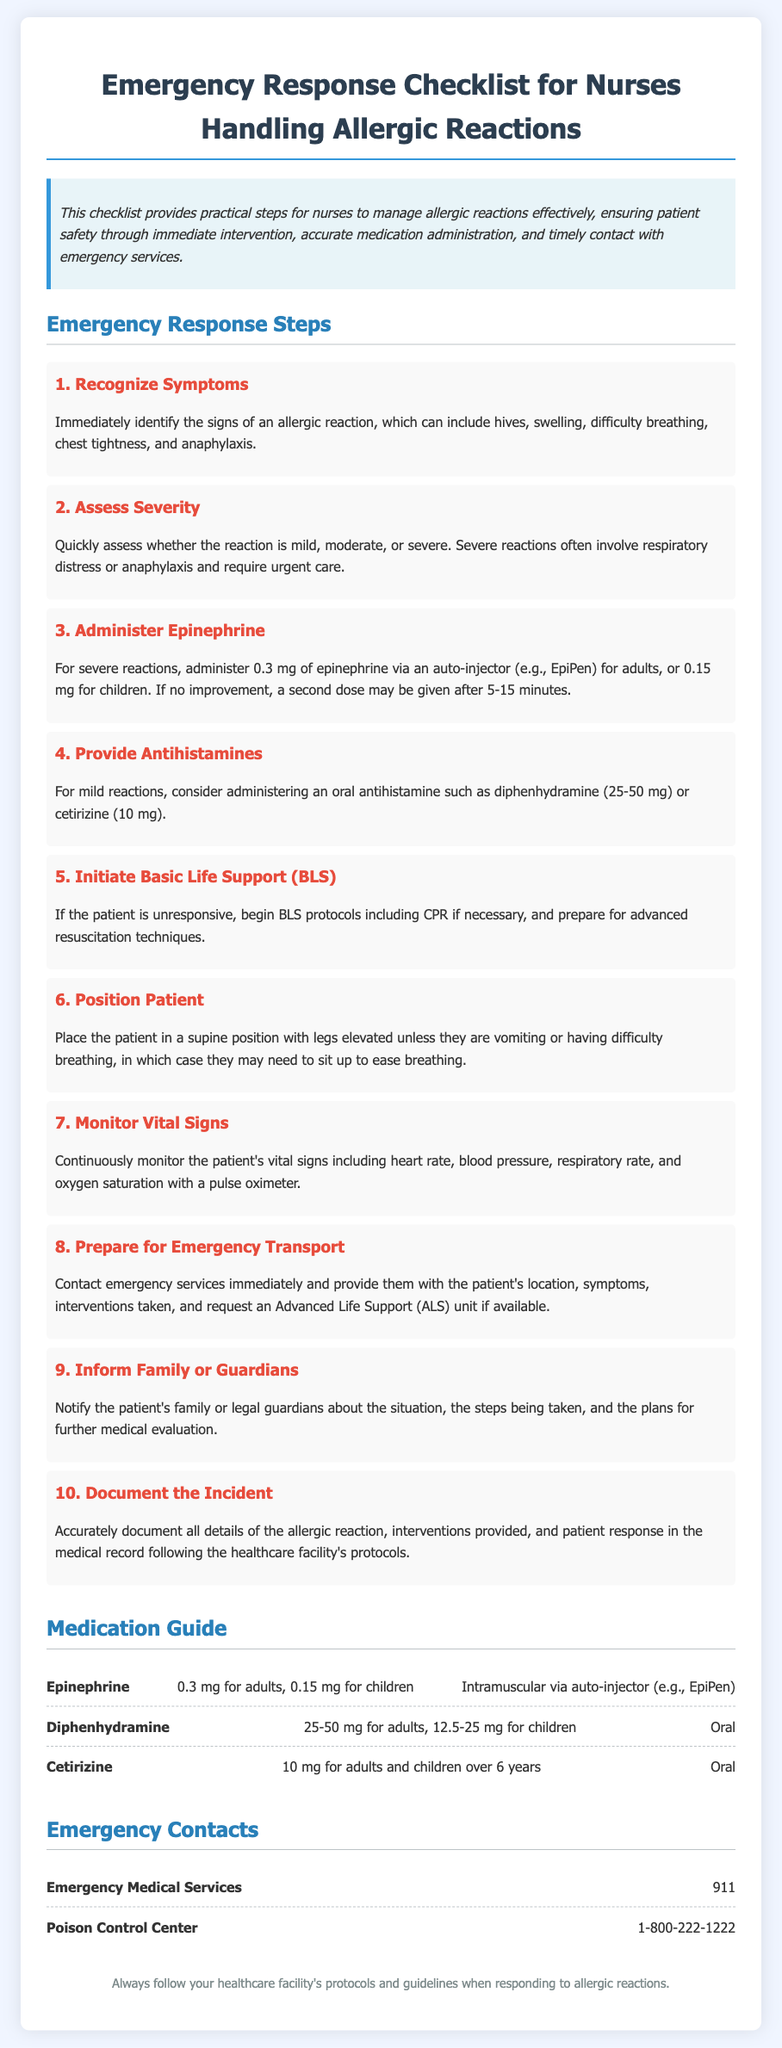What is the first step in the emergency response? The first step is to recognize the symptoms of an allergic reaction.
Answer: Recognize Symptoms What medication is administered for severe allergic reactions? The medication given for severe allergic reactions is epinephrine.
Answer: Epinephrine What dosage of epinephrine should be given to adults? For adults, the dosage of epinephrine is 0.3 mg.
Answer: 0.3 mg How long should you wait before administering a second dose of epinephrine? A second dose of epinephrine may be given after 5-15 minutes if there is no improvement.
Answer: 5-15 minutes What should be done if the patient is unresponsive? If the patient is unresponsive, begin Basic Life Support (BLS) protocols.
Answer: Begin Basic Life Support (BLS) What should the nurse do before contacting emergency services? The nurse should prepare to provide the patient's location, symptoms, and interventions taken.
Answer: Provide location and symptoms What is the contact number for Emergency Medical Services? The contact number for Emergency Medical Services is 911.
Answer: 911 How should the patient be positioned if they are having difficulty breathing? If the patient is having difficulty breathing, they may need to sit up.
Answer: Sit up What additional role does the nurse have regarding the patient's family? The nurse should inform the patient's family or guardians about the situation.
Answer: Inform family or guardians 